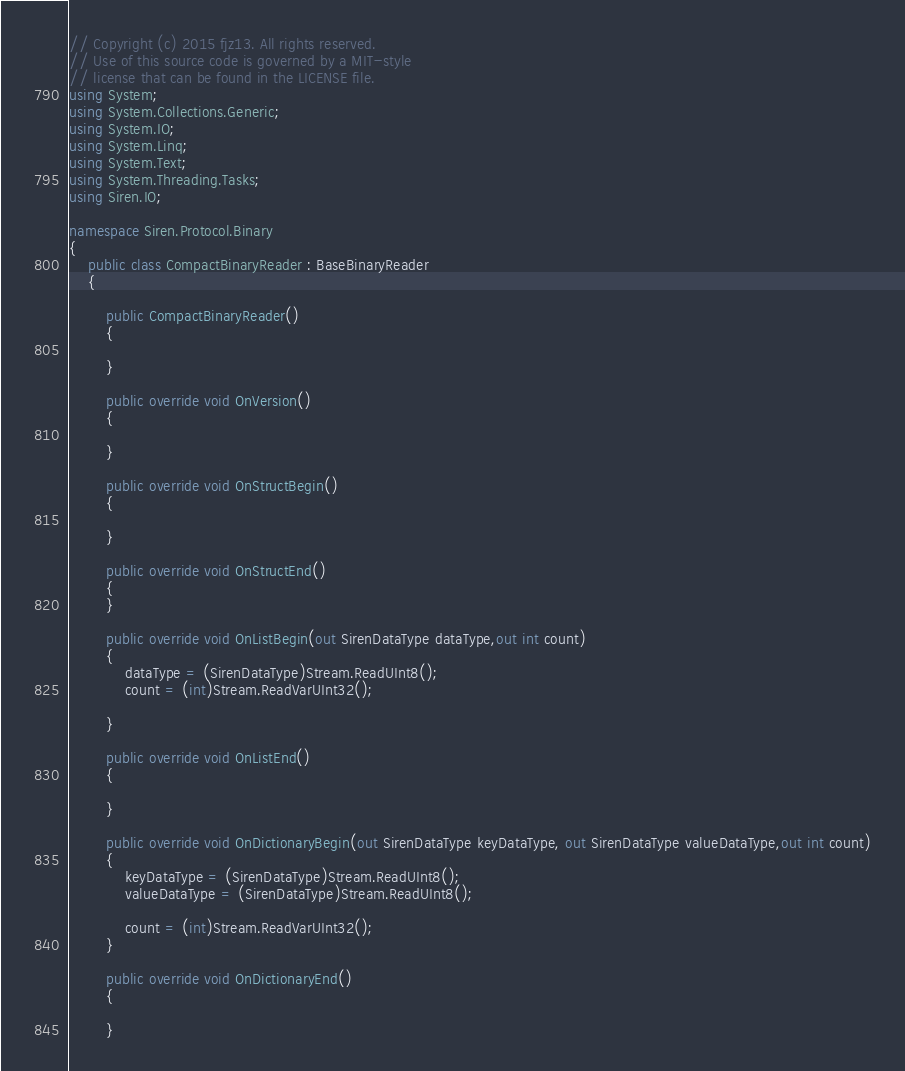<code> <loc_0><loc_0><loc_500><loc_500><_C#_>// Copyright (c) 2015 fjz13. All rights reserved.
// Use of this source code is governed by a MIT-style
// license that can be found in the LICENSE file.
using System;
using System.Collections.Generic;
using System.IO;
using System.Linq;
using System.Text;
using System.Threading.Tasks;
using Siren.IO;

namespace Siren.Protocol.Binary
{
    public class CompactBinaryReader : BaseBinaryReader
    {
       
        public CompactBinaryReader()
        {

        }

        public override void OnVersion()
        {

        }

        public override void OnStructBegin()
        {

        }

        public override void OnStructEnd()
        {
        }

        public override void OnListBegin(out SirenDataType dataType,out int count)
        {
            dataType = (SirenDataType)Stream.ReadUInt8();
            count = (int)Stream.ReadVarUInt32();

        }

        public override void OnListEnd()
        {

        }

        public override void OnDictionaryBegin(out SirenDataType keyDataType, out SirenDataType valueDataType,out int count)
        {
            keyDataType = (SirenDataType)Stream.ReadUInt8();
            valueDataType = (SirenDataType)Stream.ReadUInt8();

            count = (int)Stream.ReadVarUInt32();
        }

        public override void OnDictionaryEnd()
        {

        }
</code> 